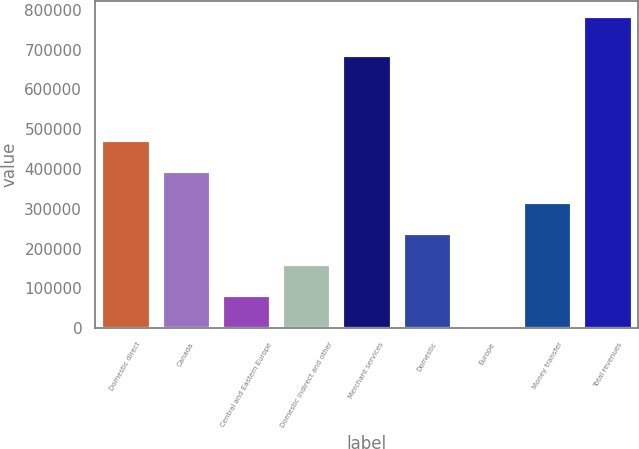Convert chart to OTSL. <chart><loc_0><loc_0><loc_500><loc_500><bar_chart><fcel>Domestic direct<fcel>Canada<fcel>Central and Eastern Europe<fcel>Domestic indirect and other<fcel>Merchant services<fcel>Domestic<fcel>Europe<fcel>Money transfer<fcel>Total revenues<nl><fcel>472605<fcel>394673<fcel>82946.6<fcel>160878<fcel>687868<fcel>238810<fcel>5015<fcel>316741<fcel>784331<nl></chart> 